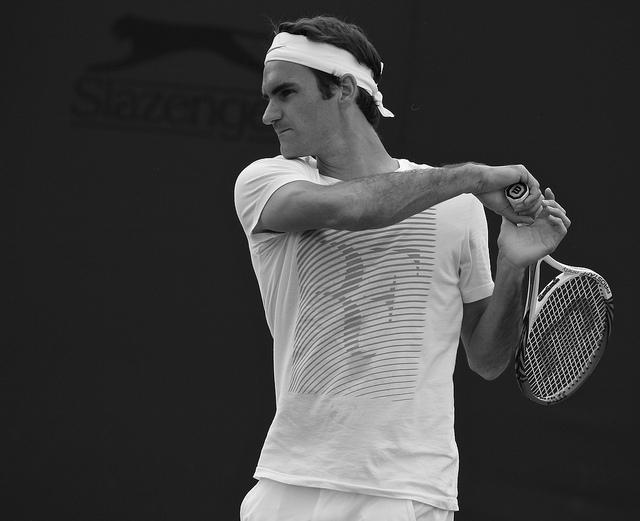Does the man need to shave?
Quick response, please. No. Is this man going to hit a golf ball?
Answer briefly. No. What is the logo on the shirt?
Write a very short answer. Rf. How many people are shown?
Write a very short answer. 1. Does the man have hair on his arms?
Write a very short answer. Yes. What brand of tennis shoes is he wearing?
Quick response, please. Nike. What color is the symbol on the man's head tie?
Quick response, please. Black. What in the man's hand?
Answer briefly. Tennis racket. 